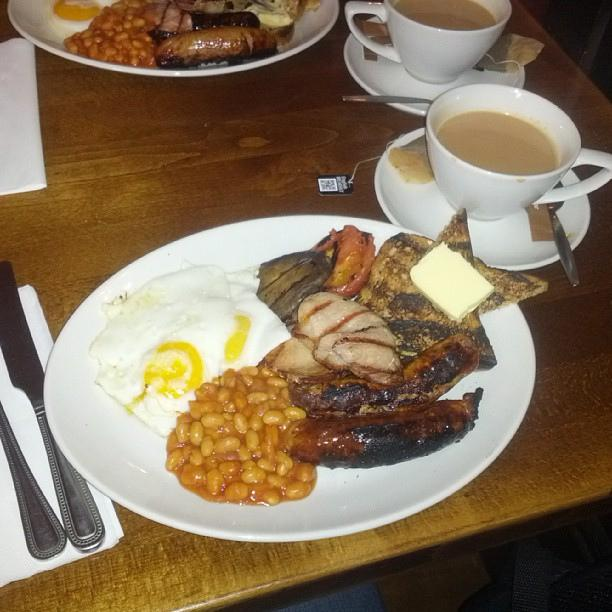What is the side dish on the plate? beans 